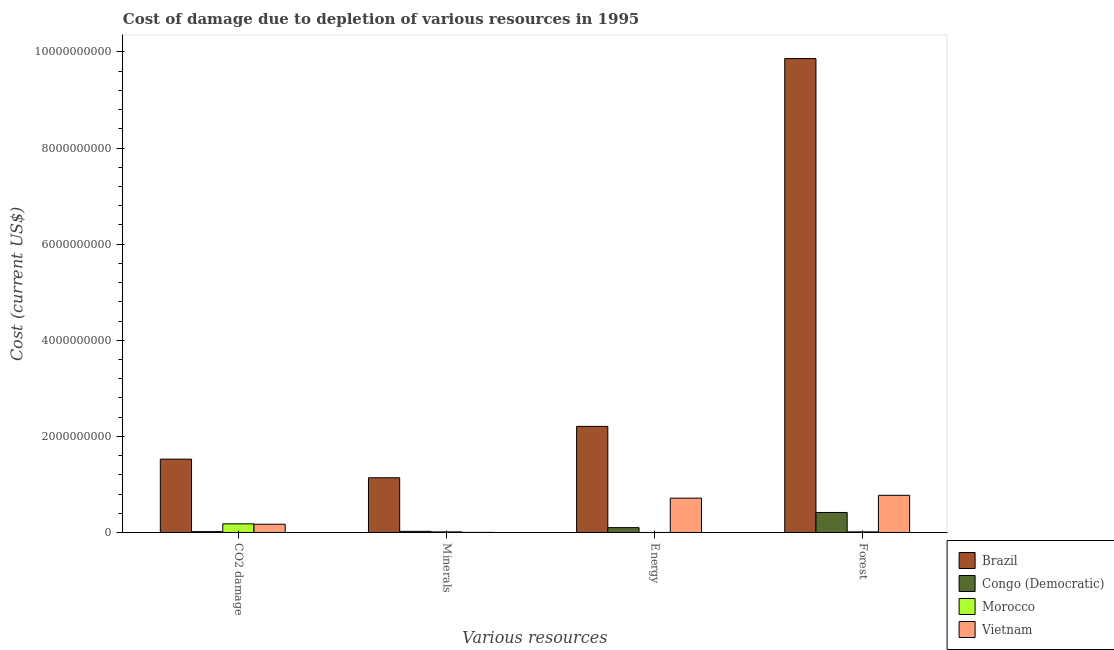How many different coloured bars are there?
Provide a short and direct response. 4. How many groups of bars are there?
Provide a succinct answer. 4. How many bars are there on the 1st tick from the right?
Ensure brevity in your answer.  4. What is the label of the 2nd group of bars from the left?
Your answer should be compact. Minerals. What is the cost of damage due to depletion of energy in Brazil?
Keep it short and to the point. 2.21e+09. Across all countries, what is the maximum cost of damage due to depletion of coal?
Make the answer very short. 1.53e+09. Across all countries, what is the minimum cost of damage due to depletion of forests?
Provide a succinct answer. 1.34e+07. In which country was the cost of damage due to depletion of forests minimum?
Ensure brevity in your answer.  Morocco. What is the total cost of damage due to depletion of forests in the graph?
Give a very brief answer. 1.11e+1. What is the difference between the cost of damage due to depletion of forests in Morocco and that in Congo (Democratic)?
Your response must be concise. -4.03e+08. What is the difference between the cost of damage due to depletion of energy in Morocco and the cost of damage due to depletion of forests in Vietnam?
Give a very brief answer. -7.73e+08. What is the average cost of damage due to depletion of minerals per country?
Provide a succinct answer. 2.94e+08. What is the difference between the cost of damage due to depletion of coal and cost of damage due to depletion of minerals in Congo (Democratic)?
Your answer should be very brief. -6.58e+06. In how many countries, is the cost of damage due to depletion of coal greater than 2800000000 US$?
Your answer should be very brief. 0. What is the ratio of the cost of damage due to depletion of coal in Brazil to that in Congo (Democratic)?
Provide a succinct answer. 87.09. Is the difference between the cost of damage due to depletion of energy in Brazil and Morocco greater than the difference between the cost of damage due to depletion of coal in Brazil and Morocco?
Keep it short and to the point. Yes. What is the difference between the highest and the second highest cost of damage due to depletion of energy?
Your answer should be compact. 1.49e+09. What is the difference between the highest and the lowest cost of damage due to depletion of forests?
Offer a terse response. 9.85e+09. In how many countries, is the cost of damage due to depletion of coal greater than the average cost of damage due to depletion of coal taken over all countries?
Your response must be concise. 1. What does the 2nd bar from the left in CO2 damage represents?
Ensure brevity in your answer.  Congo (Democratic). What does the 1st bar from the right in Minerals represents?
Offer a very short reply. Vietnam. How many bars are there?
Offer a very short reply. 16. Does the graph contain any zero values?
Provide a short and direct response. No. Does the graph contain grids?
Provide a short and direct response. No. How are the legend labels stacked?
Ensure brevity in your answer.  Vertical. What is the title of the graph?
Your response must be concise. Cost of damage due to depletion of various resources in 1995 . What is the label or title of the X-axis?
Provide a succinct answer. Various resources. What is the label or title of the Y-axis?
Ensure brevity in your answer.  Cost (current US$). What is the Cost (current US$) in Brazil in CO2 damage?
Offer a terse response. 1.53e+09. What is the Cost (current US$) in Congo (Democratic) in CO2 damage?
Your answer should be compact. 1.75e+07. What is the Cost (current US$) in Morocco in CO2 damage?
Provide a succinct answer. 1.79e+08. What is the Cost (current US$) of Vietnam in CO2 damage?
Make the answer very short. 1.72e+08. What is the Cost (current US$) of Brazil in Minerals?
Provide a succinct answer. 1.14e+09. What is the Cost (current US$) of Congo (Democratic) in Minerals?
Ensure brevity in your answer.  2.41e+07. What is the Cost (current US$) in Morocco in Minerals?
Your answer should be compact. 1.26e+07. What is the Cost (current US$) in Vietnam in Minerals?
Keep it short and to the point. 2.01e+06. What is the Cost (current US$) of Brazil in Energy?
Provide a short and direct response. 2.21e+09. What is the Cost (current US$) in Congo (Democratic) in Energy?
Ensure brevity in your answer.  1.01e+08. What is the Cost (current US$) of Morocco in Energy?
Your answer should be compact. 6.02e+05. What is the Cost (current US$) in Vietnam in Energy?
Your response must be concise. 7.15e+08. What is the Cost (current US$) in Brazil in Forest?
Ensure brevity in your answer.  9.86e+09. What is the Cost (current US$) in Congo (Democratic) in Forest?
Offer a terse response. 4.16e+08. What is the Cost (current US$) of Morocco in Forest?
Give a very brief answer. 1.34e+07. What is the Cost (current US$) of Vietnam in Forest?
Make the answer very short. 7.74e+08. Across all Various resources, what is the maximum Cost (current US$) of Brazil?
Give a very brief answer. 9.86e+09. Across all Various resources, what is the maximum Cost (current US$) of Congo (Democratic)?
Give a very brief answer. 4.16e+08. Across all Various resources, what is the maximum Cost (current US$) of Morocco?
Keep it short and to the point. 1.79e+08. Across all Various resources, what is the maximum Cost (current US$) of Vietnam?
Offer a very short reply. 7.74e+08. Across all Various resources, what is the minimum Cost (current US$) in Brazil?
Keep it short and to the point. 1.14e+09. Across all Various resources, what is the minimum Cost (current US$) in Congo (Democratic)?
Provide a succinct answer. 1.75e+07. Across all Various resources, what is the minimum Cost (current US$) of Morocco?
Give a very brief answer. 6.02e+05. Across all Various resources, what is the minimum Cost (current US$) of Vietnam?
Ensure brevity in your answer.  2.01e+06. What is the total Cost (current US$) in Brazil in the graph?
Offer a terse response. 1.47e+1. What is the total Cost (current US$) of Congo (Democratic) in the graph?
Provide a succinct answer. 5.59e+08. What is the total Cost (current US$) of Morocco in the graph?
Provide a short and direct response. 2.06e+08. What is the total Cost (current US$) of Vietnam in the graph?
Offer a very short reply. 1.66e+09. What is the difference between the Cost (current US$) of Brazil in CO2 damage and that in Minerals?
Offer a very short reply. 3.88e+08. What is the difference between the Cost (current US$) in Congo (Democratic) in CO2 damage and that in Minerals?
Your answer should be compact. -6.58e+06. What is the difference between the Cost (current US$) of Morocco in CO2 damage and that in Minerals?
Provide a succinct answer. 1.67e+08. What is the difference between the Cost (current US$) of Vietnam in CO2 damage and that in Minerals?
Give a very brief answer. 1.70e+08. What is the difference between the Cost (current US$) of Brazil in CO2 damage and that in Energy?
Ensure brevity in your answer.  -6.82e+08. What is the difference between the Cost (current US$) of Congo (Democratic) in CO2 damage and that in Energy?
Make the answer very short. -8.35e+07. What is the difference between the Cost (current US$) of Morocco in CO2 damage and that in Energy?
Provide a succinct answer. 1.79e+08. What is the difference between the Cost (current US$) of Vietnam in CO2 damage and that in Energy?
Your answer should be compact. -5.43e+08. What is the difference between the Cost (current US$) in Brazil in CO2 damage and that in Forest?
Give a very brief answer. -8.34e+09. What is the difference between the Cost (current US$) in Congo (Democratic) in CO2 damage and that in Forest?
Your answer should be compact. -3.99e+08. What is the difference between the Cost (current US$) in Morocco in CO2 damage and that in Forest?
Keep it short and to the point. 1.66e+08. What is the difference between the Cost (current US$) of Vietnam in CO2 damage and that in Forest?
Ensure brevity in your answer.  -6.02e+08. What is the difference between the Cost (current US$) of Brazil in Minerals and that in Energy?
Offer a very short reply. -1.07e+09. What is the difference between the Cost (current US$) in Congo (Democratic) in Minerals and that in Energy?
Ensure brevity in your answer.  -7.70e+07. What is the difference between the Cost (current US$) in Morocco in Minerals and that in Energy?
Give a very brief answer. 1.20e+07. What is the difference between the Cost (current US$) in Vietnam in Minerals and that in Energy?
Provide a short and direct response. -7.12e+08. What is the difference between the Cost (current US$) of Brazil in Minerals and that in Forest?
Offer a very short reply. -8.72e+09. What is the difference between the Cost (current US$) of Congo (Democratic) in Minerals and that in Forest?
Keep it short and to the point. -3.92e+08. What is the difference between the Cost (current US$) in Morocco in Minerals and that in Forest?
Give a very brief answer. -7.15e+05. What is the difference between the Cost (current US$) in Vietnam in Minerals and that in Forest?
Offer a terse response. -7.71e+08. What is the difference between the Cost (current US$) in Brazil in Energy and that in Forest?
Offer a very short reply. -7.65e+09. What is the difference between the Cost (current US$) of Congo (Democratic) in Energy and that in Forest?
Keep it short and to the point. -3.15e+08. What is the difference between the Cost (current US$) of Morocco in Energy and that in Forest?
Your answer should be very brief. -1.28e+07. What is the difference between the Cost (current US$) of Vietnam in Energy and that in Forest?
Provide a short and direct response. -5.90e+07. What is the difference between the Cost (current US$) in Brazil in CO2 damage and the Cost (current US$) in Congo (Democratic) in Minerals?
Your response must be concise. 1.50e+09. What is the difference between the Cost (current US$) of Brazil in CO2 damage and the Cost (current US$) of Morocco in Minerals?
Provide a short and direct response. 1.51e+09. What is the difference between the Cost (current US$) of Brazil in CO2 damage and the Cost (current US$) of Vietnam in Minerals?
Your response must be concise. 1.52e+09. What is the difference between the Cost (current US$) of Congo (Democratic) in CO2 damage and the Cost (current US$) of Morocco in Minerals?
Give a very brief answer. 4.89e+06. What is the difference between the Cost (current US$) in Congo (Democratic) in CO2 damage and the Cost (current US$) in Vietnam in Minerals?
Offer a terse response. 1.55e+07. What is the difference between the Cost (current US$) of Morocco in CO2 damage and the Cost (current US$) of Vietnam in Minerals?
Your response must be concise. 1.77e+08. What is the difference between the Cost (current US$) in Brazil in CO2 damage and the Cost (current US$) in Congo (Democratic) in Energy?
Ensure brevity in your answer.  1.43e+09. What is the difference between the Cost (current US$) in Brazil in CO2 damage and the Cost (current US$) in Morocco in Energy?
Your response must be concise. 1.53e+09. What is the difference between the Cost (current US$) in Brazil in CO2 damage and the Cost (current US$) in Vietnam in Energy?
Provide a succinct answer. 8.12e+08. What is the difference between the Cost (current US$) of Congo (Democratic) in CO2 damage and the Cost (current US$) of Morocco in Energy?
Keep it short and to the point. 1.69e+07. What is the difference between the Cost (current US$) in Congo (Democratic) in CO2 damage and the Cost (current US$) in Vietnam in Energy?
Your answer should be compact. -6.97e+08. What is the difference between the Cost (current US$) in Morocco in CO2 damage and the Cost (current US$) in Vietnam in Energy?
Provide a succinct answer. -5.35e+08. What is the difference between the Cost (current US$) in Brazil in CO2 damage and the Cost (current US$) in Congo (Democratic) in Forest?
Offer a terse response. 1.11e+09. What is the difference between the Cost (current US$) in Brazil in CO2 damage and the Cost (current US$) in Morocco in Forest?
Provide a short and direct response. 1.51e+09. What is the difference between the Cost (current US$) in Brazil in CO2 damage and the Cost (current US$) in Vietnam in Forest?
Make the answer very short. 7.53e+08. What is the difference between the Cost (current US$) in Congo (Democratic) in CO2 damage and the Cost (current US$) in Morocco in Forest?
Offer a very short reply. 4.17e+06. What is the difference between the Cost (current US$) in Congo (Democratic) in CO2 damage and the Cost (current US$) in Vietnam in Forest?
Your response must be concise. -7.56e+08. What is the difference between the Cost (current US$) in Morocco in CO2 damage and the Cost (current US$) in Vietnam in Forest?
Make the answer very short. -5.94e+08. What is the difference between the Cost (current US$) of Brazil in Minerals and the Cost (current US$) of Congo (Democratic) in Energy?
Give a very brief answer. 1.04e+09. What is the difference between the Cost (current US$) of Brazil in Minerals and the Cost (current US$) of Morocco in Energy?
Keep it short and to the point. 1.14e+09. What is the difference between the Cost (current US$) in Brazil in Minerals and the Cost (current US$) in Vietnam in Energy?
Your answer should be compact. 4.24e+08. What is the difference between the Cost (current US$) in Congo (Democratic) in Minerals and the Cost (current US$) in Morocco in Energy?
Provide a short and direct response. 2.35e+07. What is the difference between the Cost (current US$) of Congo (Democratic) in Minerals and the Cost (current US$) of Vietnam in Energy?
Make the answer very short. -6.90e+08. What is the difference between the Cost (current US$) of Morocco in Minerals and the Cost (current US$) of Vietnam in Energy?
Provide a short and direct response. -7.02e+08. What is the difference between the Cost (current US$) in Brazil in Minerals and the Cost (current US$) in Congo (Democratic) in Forest?
Keep it short and to the point. 7.22e+08. What is the difference between the Cost (current US$) of Brazil in Minerals and the Cost (current US$) of Morocco in Forest?
Ensure brevity in your answer.  1.13e+09. What is the difference between the Cost (current US$) in Brazil in Minerals and the Cost (current US$) in Vietnam in Forest?
Ensure brevity in your answer.  3.65e+08. What is the difference between the Cost (current US$) of Congo (Democratic) in Minerals and the Cost (current US$) of Morocco in Forest?
Keep it short and to the point. 1.08e+07. What is the difference between the Cost (current US$) in Congo (Democratic) in Minerals and the Cost (current US$) in Vietnam in Forest?
Offer a terse response. -7.49e+08. What is the difference between the Cost (current US$) in Morocco in Minerals and the Cost (current US$) in Vietnam in Forest?
Your answer should be very brief. -7.61e+08. What is the difference between the Cost (current US$) of Brazil in Energy and the Cost (current US$) of Congo (Democratic) in Forest?
Give a very brief answer. 1.79e+09. What is the difference between the Cost (current US$) of Brazil in Energy and the Cost (current US$) of Morocco in Forest?
Make the answer very short. 2.19e+09. What is the difference between the Cost (current US$) of Brazil in Energy and the Cost (current US$) of Vietnam in Forest?
Provide a short and direct response. 1.43e+09. What is the difference between the Cost (current US$) of Congo (Democratic) in Energy and the Cost (current US$) of Morocco in Forest?
Offer a terse response. 8.77e+07. What is the difference between the Cost (current US$) of Congo (Democratic) in Energy and the Cost (current US$) of Vietnam in Forest?
Your response must be concise. -6.72e+08. What is the difference between the Cost (current US$) in Morocco in Energy and the Cost (current US$) in Vietnam in Forest?
Offer a terse response. -7.73e+08. What is the average Cost (current US$) of Brazil per Various resources?
Provide a succinct answer. 3.68e+09. What is the average Cost (current US$) in Congo (Democratic) per Various resources?
Make the answer very short. 1.40e+08. What is the average Cost (current US$) of Morocco per Various resources?
Provide a succinct answer. 5.15e+07. What is the average Cost (current US$) of Vietnam per Various resources?
Provide a succinct answer. 4.15e+08. What is the difference between the Cost (current US$) of Brazil and Cost (current US$) of Congo (Democratic) in CO2 damage?
Make the answer very short. 1.51e+09. What is the difference between the Cost (current US$) in Brazil and Cost (current US$) in Morocco in CO2 damage?
Make the answer very short. 1.35e+09. What is the difference between the Cost (current US$) of Brazil and Cost (current US$) of Vietnam in CO2 damage?
Make the answer very short. 1.35e+09. What is the difference between the Cost (current US$) in Congo (Democratic) and Cost (current US$) in Morocco in CO2 damage?
Provide a succinct answer. -1.62e+08. What is the difference between the Cost (current US$) in Congo (Democratic) and Cost (current US$) in Vietnam in CO2 damage?
Provide a short and direct response. -1.54e+08. What is the difference between the Cost (current US$) of Morocco and Cost (current US$) of Vietnam in CO2 damage?
Keep it short and to the point. 7.58e+06. What is the difference between the Cost (current US$) of Brazil and Cost (current US$) of Congo (Democratic) in Minerals?
Your answer should be compact. 1.11e+09. What is the difference between the Cost (current US$) in Brazil and Cost (current US$) in Morocco in Minerals?
Offer a very short reply. 1.13e+09. What is the difference between the Cost (current US$) in Brazil and Cost (current US$) in Vietnam in Minerals?
Give a very brief answer. 1.14e+09. What is the difference between the Cost (current US$) in Congo (Democratic) and Cost (current US$) in Morocco in Minerals?
Your answer should be compact. 1.15e+07. What is the difference between the Cost (current US$) of Congo (Democratic) and Cost (current US$) of Vietnam in Minerals?
Make the answer very short. 2.21e+07. What is the difference between the Cost (current US$) of Morocco and Cost (current US$) of Vietnam in Minerals?
Provide a short and direct response. 1.06e+07. What is the difference between the Cost (current US$) in Brazil and Cost (current US$) in Congo (Democratic) in Energy?
Give a very brief answer. 2.11e+09. What is the difference between the Cost (current US$) in Brazil and Cost (current US$) in Morocco in Energy?
Keep it short and to the point. 2.21e+09. What is the difference between the Cost (current US$) of Brazil and Cost (current US$) of Vietnam in Energy?
Make the answer very short. 1.49e+09. What is the difference between the Cost (current US$) of Congo (Democratic) and Cost (current US$) of Morocco in Energy?
Ensure brevity in your answer.  1.00e+08. What is the difference between the Cost (current US$) in Congo (Democratic) and Cost (current US$) in Vietnam in Energy?
Provide a short and direct response. -6.13e+08. What is the difference between the Cost (current US$) in Morocco and Cost (current US$) in Vietnam in Energy?
Your answer should be very brief. -7.14e+08. What is the difference between the Cost (current US$) of Brazil and Cost (current US$) of Congo (Democratic) in Forest?
Your answer should be compact. 9.45e+09. What is the difference between the Cost (current US$) of Brazil and Cost (current US$) of Morocco in Forest?
Make the answer very short. 9.85e+09. What is the difference between the Cost (current US$) of Brazil and Cost (current US$) of Vietnam in Forest?
Provide a short and direct response. 9.09e+09. What is the difference between the Cost (current US$) in Congo (Democratic) and Cost (current US$) in Morocco in Forest?
Offer a very short reply. 4.03e+08. What is the difference between the Cost (current US$) of Congo (Democratic) and Cost (current US$) of Vietnam in Forest?
Offer a very short reply. -3.57e+08. What is the difference between the Cost (current US$) in Morocco and Cost (current US$) in Vietnam in Forest?
Offer a terse response. -7.60e+08. What is the ratio of the Cost (current US$) in Brazil in CO2 damage to that in Minerals?
Provide a succinct answer. 1.34. What is the ratio of the Cost (current US$) of Congo (Democratic) in CO2 damage to that in Minerals?
Give a very brief answer. 0.73. What is the ratio of the Cost (current US$) of Morocco in CO2 damage to that in Minerals?
Offer a terse response. 14.2. What is the ratio of the Cost (current US$) in Vietnam in CO2 damage to that in Minerals?
Keep it short and to the point. 85.32. What is the ratio of the Cost (current US$) of Brazil in CO2 damage to that in Energy?
Offer a very short reply. 0.69. What is the ratio of the Cost (current US$) of Congo (Democratic) in CO2 damage to that in Energy?
Your response must be concise. 0.17. What is the ratio of the Cost (current US$) of Morocco in CO2 damage to that in Energy?
Ensure brevity in your answer.  297.91. What is the ratio of the Cost (current US$) of Vietnam in CO2 damage to that in Energy?
Your response must be concise. 0.24. What is the ratio of the Cost (current US$) of Brazil in CO2 damage to that in Forest?
Your response must be concise. 0.15. What is the ratio of the Cost (current US$) in Congo (Democratic) in CO2 damage to that in Forest?
Keep it short and to the point. 0.04. What is the ratio of the Cost (current US$) of Morocco in CO2 damage to that in Forest?
Your answer should be compact. 13.44. What is the ratio of the Cost (current US$) in Vietnam in CO2 damage to that in Forest?
Your answer should be very brief. 0.22. What is the ratio of the Cost (current US$) of Brazil in Minerals to that in Energy?
Your answer should be compact. 0.52. What is the ratio of the Cost (current US$) of Congo (Democratic) in Minerals to that in Energy?
Your answer should be compact. 0.24. What is the ratio of the Cost (current US$) of Morocco in Minerals to that in Energy?
Provide a succinct answer. 20.98. What is the ratio of the Cost (current US$) in Vietnam in Minerals to that in Energy?
Make the answer very short. 0. What is the ratio of the Cost (current US$) in Brazil in Minerals to that in Forest?
Your response must be concise. 0.12. What is the ratio of the Cost (current US$) of Congo (Democratic) in Minerals to that in Forest?
Keep it short and to the point. 0.06. What is the ratio of the Cost (current US$) in Morocco in Minerals to that in Forest?
Make the answer very short. 0.95. What is the ratio of the Cost (current US$) in Vietnam in Minerals to that in Forest?
Keep it short and to the point. 0. What is the ratio of the Cost (current US$) of Brazil in Energy to that in Forest?
Your answer should be very brief. 0.22. What is the ratio of the Cost (current US$) of Congo (Democratic) in Energy to that in Forest?
Provide a short and direct response. 0.24. What is the ratio of the Cost (current US$) in Morocco in Energy to that in Forest?
Offer a terse response. 0.05. What is the ratio of the Cost (current US$) in Vietnam in Energy to that in Forest?
Your answer should be compact. 0.92. What is the difference between the highest and the second highest Cost (current US$) in Brazil?
Your answer should be very brief. 7.65e+09. What is the difference between the highest and the second highest Cost (current US$) in Congo (Democratic)?
Your response must be concise. 3.15e+08. What is the difference between the highest and the second highest Cost (current US$) in Morocco?
Your answer should be compact. 1.66e+08. What is the difference between the highest and the second highest Cost (current US$) of Vietnam?
Offer a terse response. 5.90e+07. What is the difference between the highest and the lowest Cost (current US$) of Brazil?
Ensure brevity in your answer.  8.72e+09. What is the difference between the highest and the lowest Cost (current US$) in Congo (Democratic)?
Provide a succinct answer. 3.99e+08. What is the difference between the highest and the lowest Cost (current US$) of Morocco?
Ensure brevity in your answer.  1.79e+08. What is the difference between the highest and the lowest Cost (current US$) in Vietnam?
Provide a short and direct response. 7.71e+08. 